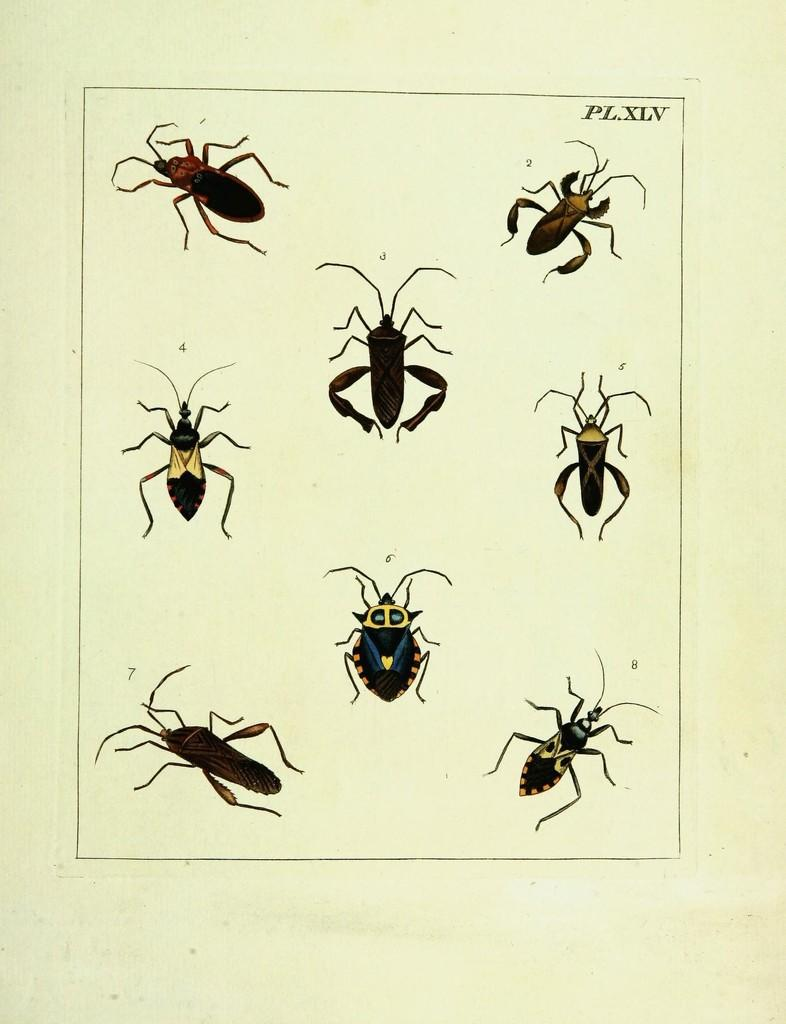What is depicted on the paper in the image? There are insects drawn on the paper. What is the color of the paper? The paper is in white color. What word is written on the paper by the boy in the image? There is no boy present in the image, and no word is written on the paper. The image only shows insects drawn on a white paper. 